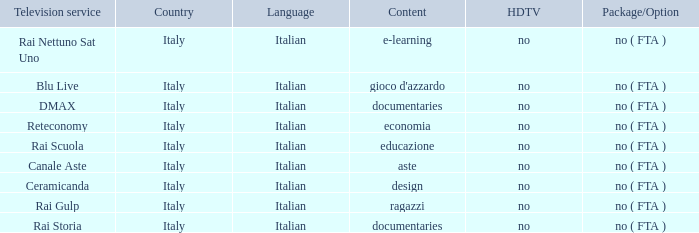What is the Language for Canale Aste? Italian. 